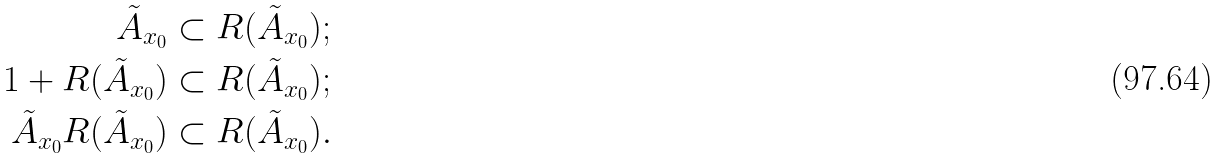<formula> <loc_0><loc_0><loc_500><loc_500>\tilde { A } _ { x _ { 0 } } & \subset R ( \tilde { A } _ { x _ { 0 } } ) ; \\ 1 + R ( \tilde { A } _ { x _ { 0 } } ) & \subset R ( \tilde { A } _ { x _ { 0 } } ) ; \\ \tilde { A } _ { x _ { 0 } } R ( \tilde { A } _ { x _ { 0 } } ) & \subset R ( \tilde { A } _ { x _ { 0 } } ) .</formula> 